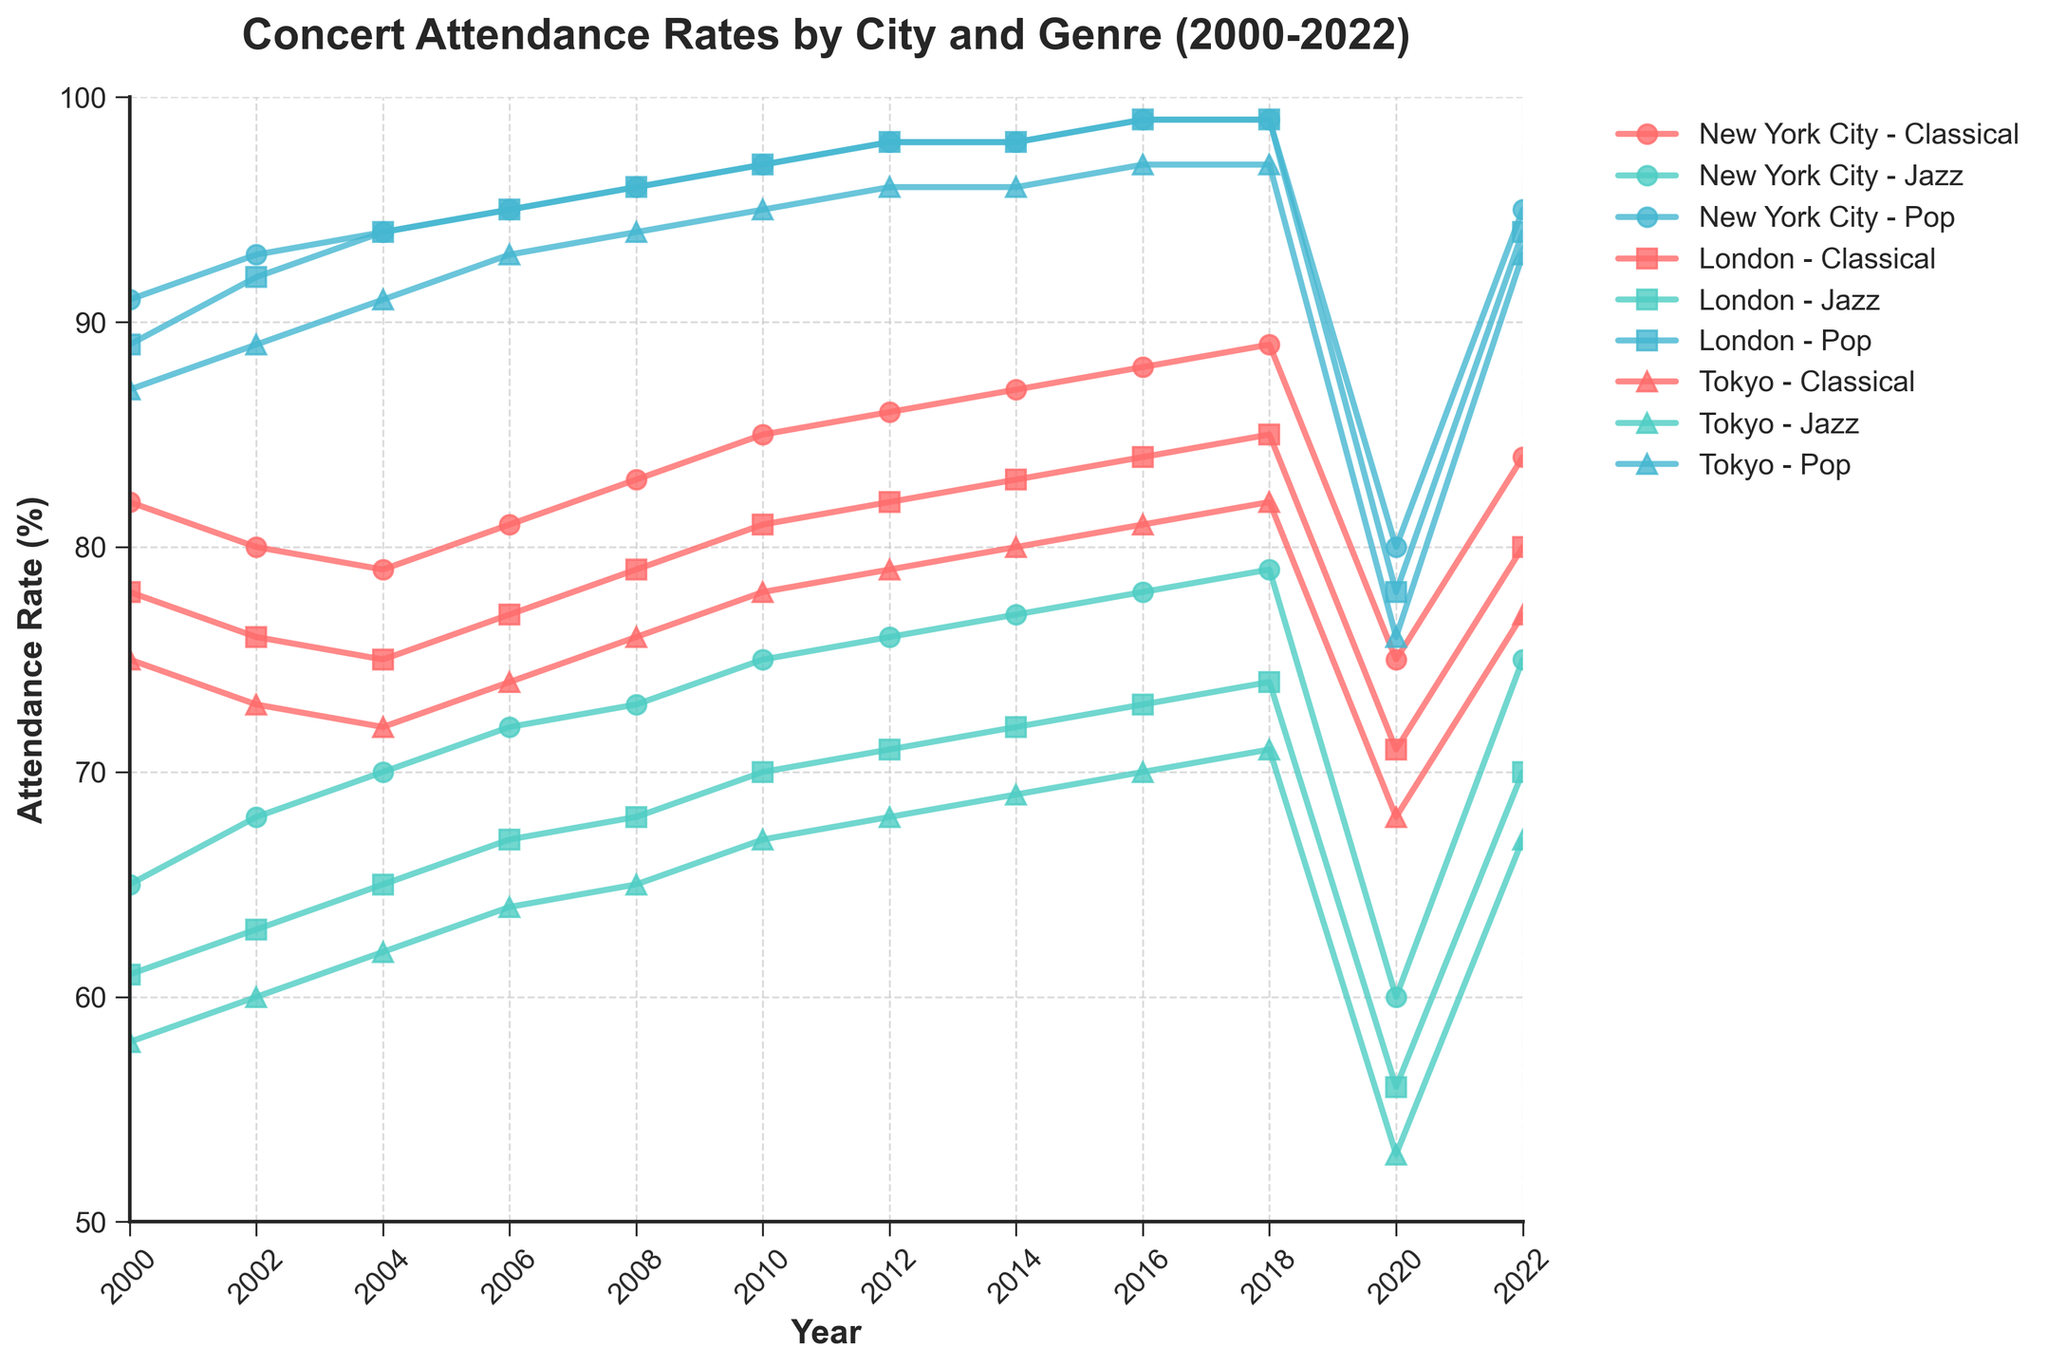What was the attendance rate for New York City Jazz in 2018? The plot shows the attendance rates over different years, specifically for New York City Jazz in 2018. We locate the 2018 marker on the 'New York City Jazz' line and read the value.
Answer: 79 Did classical concert attendance in London ever surpass classical concert attendance in New York City? By comparing the 'London Classical' and 'New York City Classical' lines across the years, we look for instances where the London line is above the New York City line. This does not occur.
Answer: No In which year did Tokyo have the lowest attendance rate for jazz concerts? We examine the 'Tokyo Jazz' line to find the lowest point, and look at the year associated with this point.
Answer: 2020 Which genre consistently had the highest attendance rates across all three cities? By comparing the peaks and trends of all three genres (Classical, Jazz, Pop) across the cities, we observe that the 'Pop' line is generally the highest.
Answer: Pop What year shows the most significant drop in attendance rates across all genres and cities? We identify the year where most lines show a noticeable decline. The year is marked and we check if this year (2020) shows drops across different genres in all cities.
Answer: 2020 How did the attendance rates for classical concerts in New York City change from 2020 to 2022? We observe the 'New York City Classical' line and compare the point at 2020 with the point at 2022.
Answer: Increased What is the difference in pop concert attendance rates between 2000 and 2018 in Tokyo? Find the values for 'Tokyo Pop' at 2000 and 2018, then calculate the difference: 97 - 87.
Answer: 10 Which city showed the quickest recovery in jazz concert attendance from 2020 to 2022? By comparing the increase in jazz attendance rates for New York City, London, and Tokyo between 2020 and 2022, we observe the steepest increase.
Answer: New York City Between New York City and London, which city had a higher attendance rate for classical concerts in 2006? Locate the values for 'New York City Classical' and 'London Classical' in 2006 and compare them.
Answer: New York City What can you infer about the trend of jazz music attendance in London from 2000 to 2022? Analyze the 'London Jazz' line from 2000 to 2022. Note the rise and fall, concluding with a moderate increase by 2022.
Answer: General upward trend 